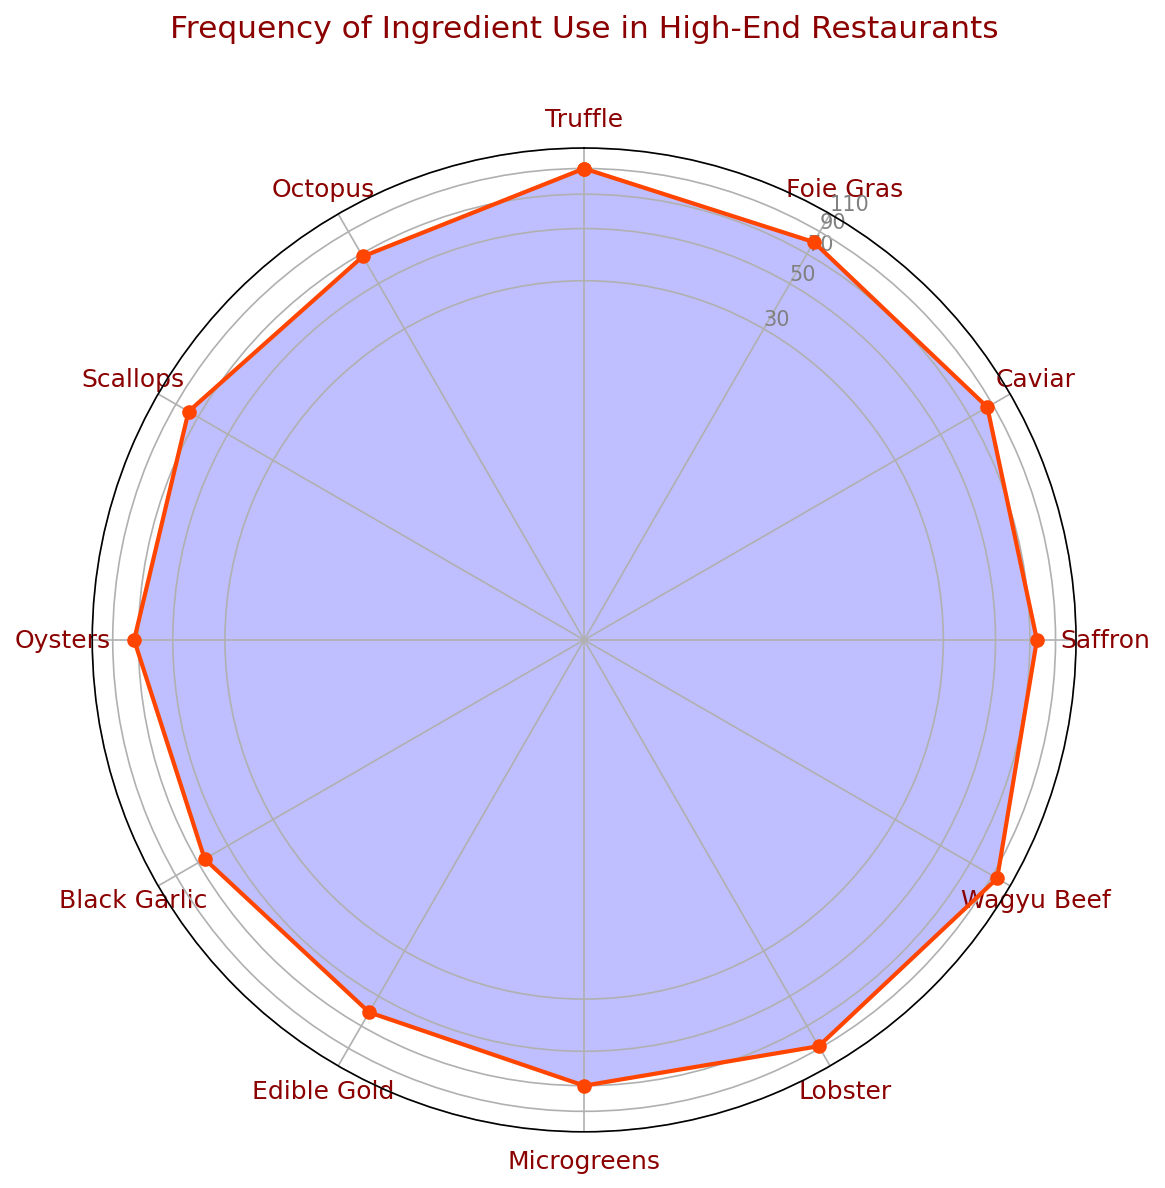What ingredient has the highest usage frequency? Upon examining the plot, the ingredient with the highest value on the radial axis is Wagyu Beef.
Answer: Wagyu Beef Which ingredient has a lower usage frequency, Microgreens or Saffron? Looking at the placement on the radar chart, Microgreens is at 70 and Saffron is at 75, so Microgreens has a lower usage frequency.
Answer: Microgreens What is the average usage frequency of Truffle, Caviar, and Lobster? Adding their frequencies (Truffle: 90, Caviar: 85, Lobster: 88) gives a total of 263. Dividing by 3, the average usage frequency is 263/3 = 87.67.
Answer: 87.67 Which ingredient has the closest usage frequency to Black Garlic? Referencing the chart, Oyster has a usage frequency of 73, which is closest to Black Garlic's 65.
Answer: Oysters How many ingredients have a usage frequency of 80 or higher? Counting the data points on the chart, the ingredients are Truffle (90), Foie Gras (80), Caviar (85), Wagyu Beef (95), and Lobster (88), which sums up to 5 ingredients.
Answer: 5 What is the difference in usage frequency between Edible Gold and Scallops? Scallops have a usage frequency of 78, and Edible Gold has 60. The difference is 78 - 60 = 18.
Answer: 18 What is the most frequently used seafood ingredient? Looking at the seafood ingredients (Lobster, Oysters, Scallops, Octopus), Lobster has the highest frequency at 88.
Answer: Lobster Which ingredient is used more frequently, Octopus or Microgreens? The chart shows that Octopus has a usage frequency of 68, while Microgreens have 70, so Microgreens are used more frequently.
Answer: Microgreens What is the total usage frequency of Foie Gras, Black Garlic, and Octopus? Summing their frequencies: Foie Gras (80), Black Garlic (65), and Octopus (68) totals 213.
Answer: 213 Which ingredient has a higher usage frequency, Caviar or Oysters? Referring to the chart, Caviar has a usage frequency of 85, while Oysters have 73, so Caviar has a higher frequency.
Answer: Caviar 